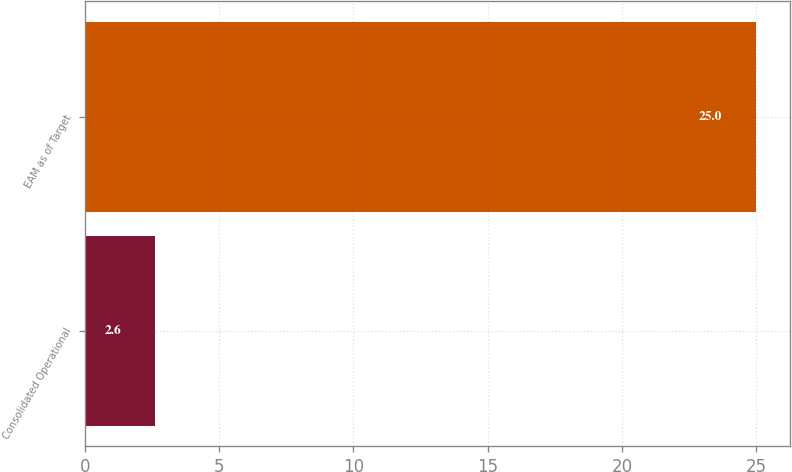Convert chart. <chart><loc_0><loc_0><loc_500><loc_500><bar_chart><fcel>Consolidated Operational<fcel>EAM as of Target<nl><fcel>2.6<fcel>25<nl></chart> 